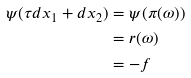Convert formula to latex. <formula><loc_0><loc_0><loc_500><loc_500>\psi ( \tau d x _ { 1 } + d x _ { 2 } ) & = \psi ( \pi ( \omega ) ) \\ & = r ( \omega ) \\ & = - f</formula> 